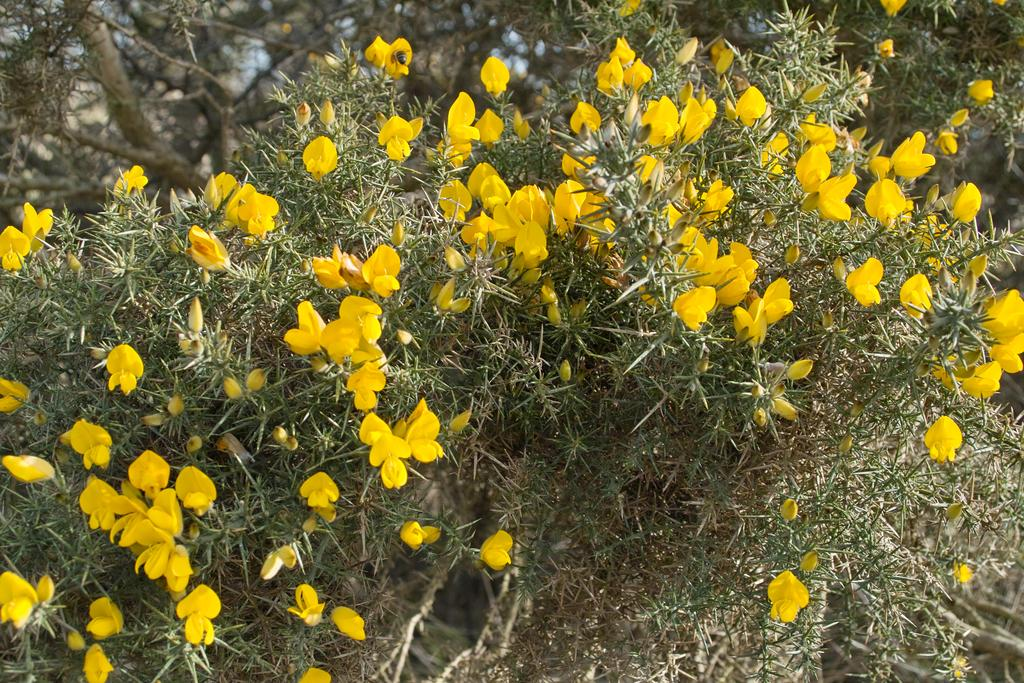What color are the flowers in the image? The flowers in the image are yellow. What are the flowers growing on? The flowers are on plants. What can be seen in the background of the image? There are trees in the background of the image. How many kittens are playing under the hat in the image? There are no kittens or hats present in the image. 